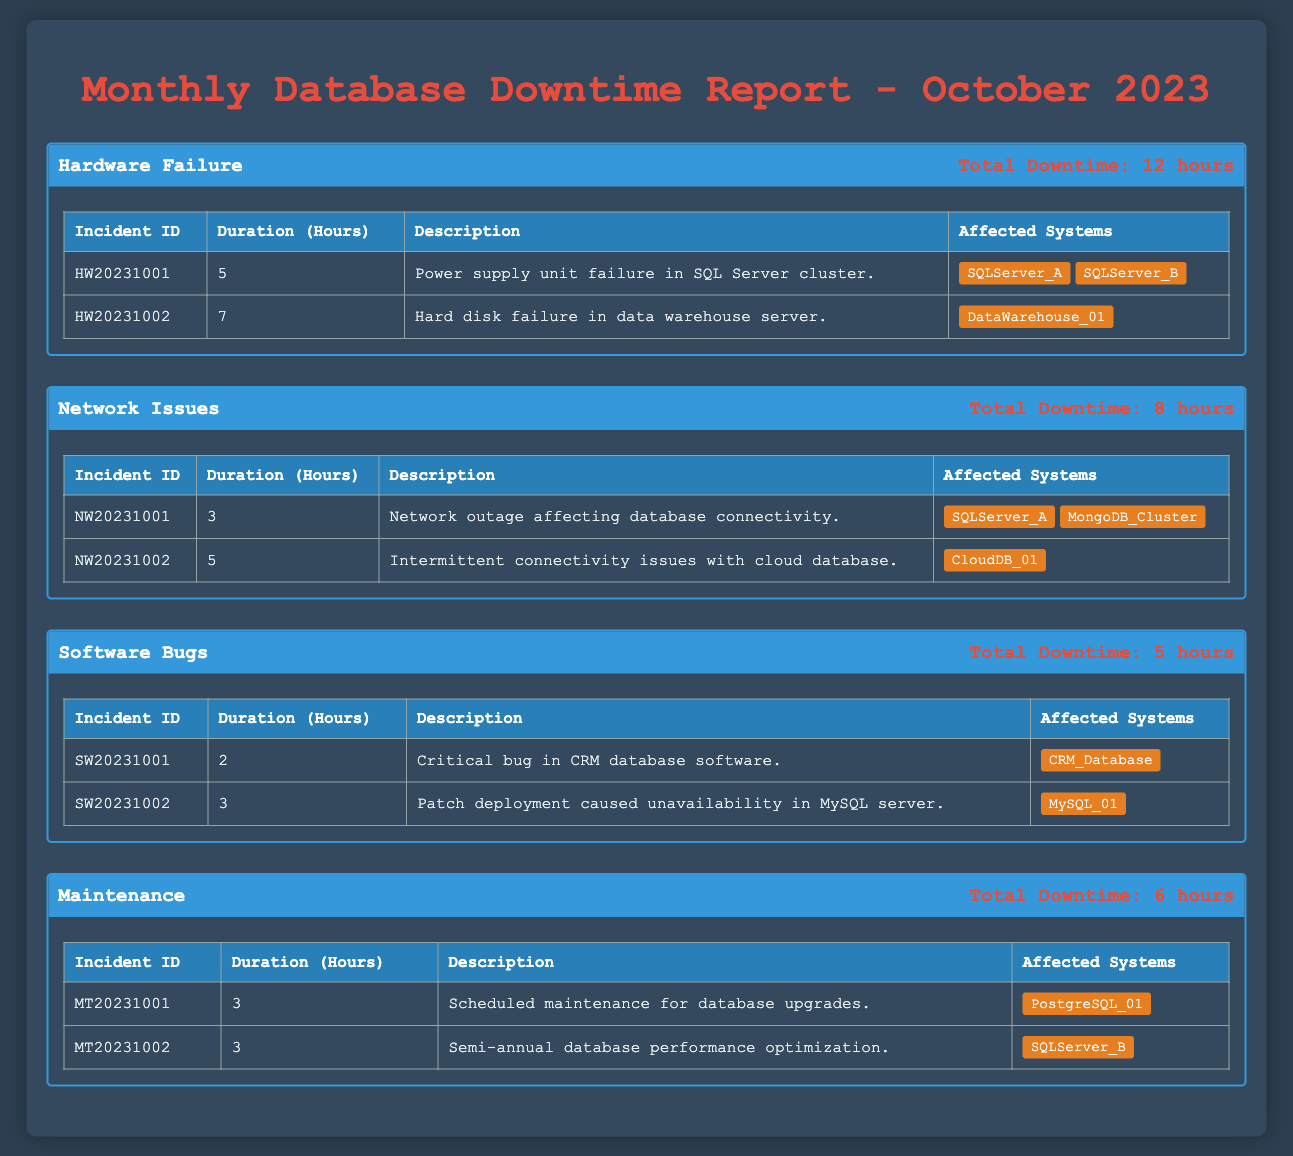What is the total downtime caused by Hardware Failure incidents? The total downtime for Hardware Failure is directly available in the table under the "Total Downtime" for that incident type, which states 12 hours.
Answer: 12 hours How many incidents were reported for Network Issues? By examining the "Incidents" section under "Network Issues," we can see there are 2 recorded incidents listed: NW20231001 and NW20231002.
Answer: 2 incidents What was the duration of the longest incident in the Software Bugs category? In the table for Software Bugs, we compare the durations of the two incidents: SW20231001 has 2 hours and SW20231002 has 3 hours. The longest duration is 3 hours.
Answer: 3 hours What percentage of total downtime in October 2023 was for Maintenance? First, we sum the total downtime for all incident types: 12 (Hardware) + 8 (Network) + 5 (Software) + 6 (Maintenance) = 31 hours. Then, for Maintenance, we have 6 hours. The percentage is (6/31) * 100 ≈ 19.35%.
Answer: Approximately 19.35% Did any incident with a description about "database connectivity" have a longer duration than 4 hours? Looking at the incidents under Network Issues, there are two descriptions mentioning database connectivity: "Network outage affecting database connectivity" (3 hours) and "Intermittent connectivity issues with cloud database" (5 hours). Since 5 hours is longer than 4 hours, the answer is yes.
Answer: Yes What is the average downtime hours per incident type in the report? To find the average downtime hours per incident type, we divide the total downtime of each incident type by the number of incidents within that type. Calculating: Hardware (12/2 = 6), Network (8/2 = 4), Software (5/2 = 2.5), Maintenance (6/2 = 3). The average downtime hours per incident type overall is then (6 + 4 + 2.5 + 3) / 4 = 3.625.
Answer: 3.625 Which incident had the longest downtime, and what was its ID? We analyze the durations of all incidents: HW20231001 (5 hours), HW20231002 (7 hours), NW20231001 (3 hours), NW20231002 (5 hours), SW20231001 (2 hours), SW20231002 (3 hours), MT20231001 (3 hours), and MT20231002 (3 hours). The longest duration is 7 hours associated with incident ID HW20231002.
Answer: HW20231002 Are there any incidents related to "power supply" mentioned in the table? Upon reviewing the descriptions in the incidents, the textual entry "Power supply unit failure in SQL Server cluster" is identified under Hardware Failure as HW20231001, indicating that there is indeed such an incident.
Answer: Yes How many affected systems were there for all incidents combined? We can sum the affected systems from each incident. Hardware Failure has 3 systems (SQLServer_A, SQLServer_B, DataWarehouse_01), Network Issues has 3 systems (SQLServer_A, MongoDB_Cluster, CloudDB_01), Software Bugs has 2 systems (CRM_Database, MySQL_01), and Maintenance has 2 systems (PostgreSQL_01, SQLServer_B). Adding these gives 3 + 3 + 2 + 2 = 10 unique affected systems.
Answer: 10 unique systems 